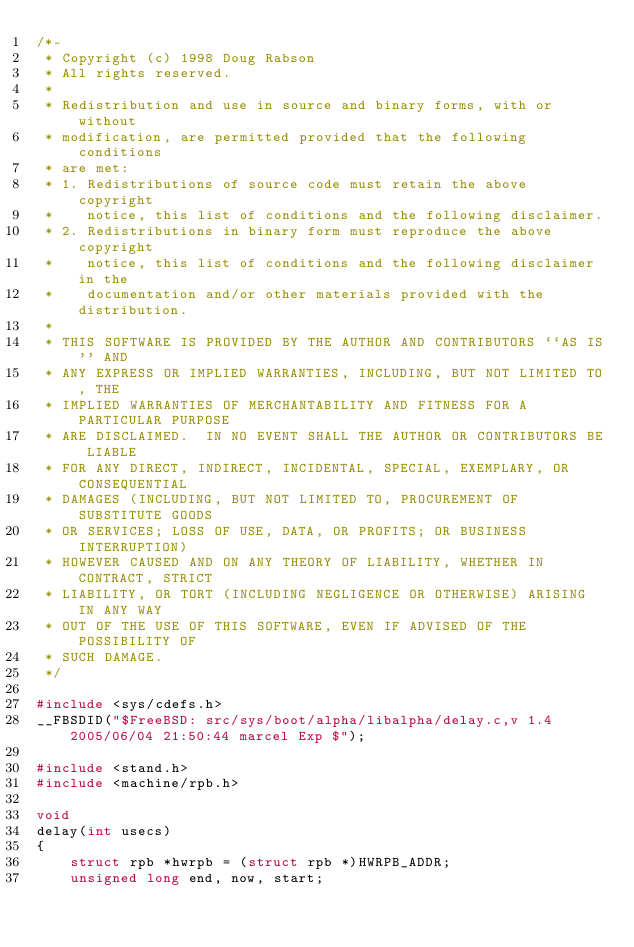Convert code to text. <code><loc_0><loc_0><loc_500><loc_500><_C_>/*-
 * Copyright (c) 1998 Doug Rabson
 * All rights reserved.
 *
 * Redistribution and use in source and binary forms, with or without
 * modification, are permitted provided that the following conditions
 * are met:
 * 1. Redistributions of source code must retain the above copyright
 *    notice, this list of conditions and the following disclaimer.
 * 2. Redistributions in binary form must reproduce the above copyright
 *    notice, this list of conditions and the following disclaimer in the
 *    documentation and/or other materials provided with the distribution.
 *
 * THIS SOFTWARE IS PROVIDED BY THE AUTHOR AND CONTRIBUTORS ``AS IS'' AND
 * ANY EXPRESS OR IMPLIED WARRANTIES, INCLUDING, BUT NOT LIMITED TO, THE
 * IMPLIED WARRANTIES OF MERCHANTABILITY AND FITNESS FOR A PARTICULAR PURPOSE
 * ARE DISCLAIMED.  IN NO EVENT SHALL THE AUTHOR OR CONTRIBUTORS BE LIABLE
 * FOR ANY DIRECT, INDIRECT, INCIDENTAL, SPECIAL, EXEMPLARY, OR CONSEQUENTIAL
 * DAMAGES (INCLUDING, BUT NOT LIMITED TO, PROCUREMENT OF SUBSTITUTE GOODS
 * OR SERVICES; LOSS OF USE, DATA, OR PROFITS; OR BUSINESS INTERRUPTION)
 * HOWEVER CAUSED AND ON ANY THEORY OF LIABILITY, WHETHER IN CONTRACT, STRICT
 * LIABILITY, OR TORT (INCLUDING NEGLIGENCE OR OTHERWISE) ARISING IN ANY WAY
 * OUT OF THE USE OF THIS SOFTWARE, EVEN IF ADVISED OF THE POSSIBILITY OF
 * SUCH DAMAGE.
 */

#include <sys/cdefs.h>
__FBSDID("$FreeBSD: src/sys/boot/alpha/libalpha/delay.c,v 1.4 2005/06/04 21:50:44 marcel Exp $");

#include <stand.h>
#include <machine/rpb.h>

void
delay(int usecs)
{
	struct rpb *hwrpb = (struct rpb *)HWRPB_ADDR;
	unsigned long end, now, start;
</code> 